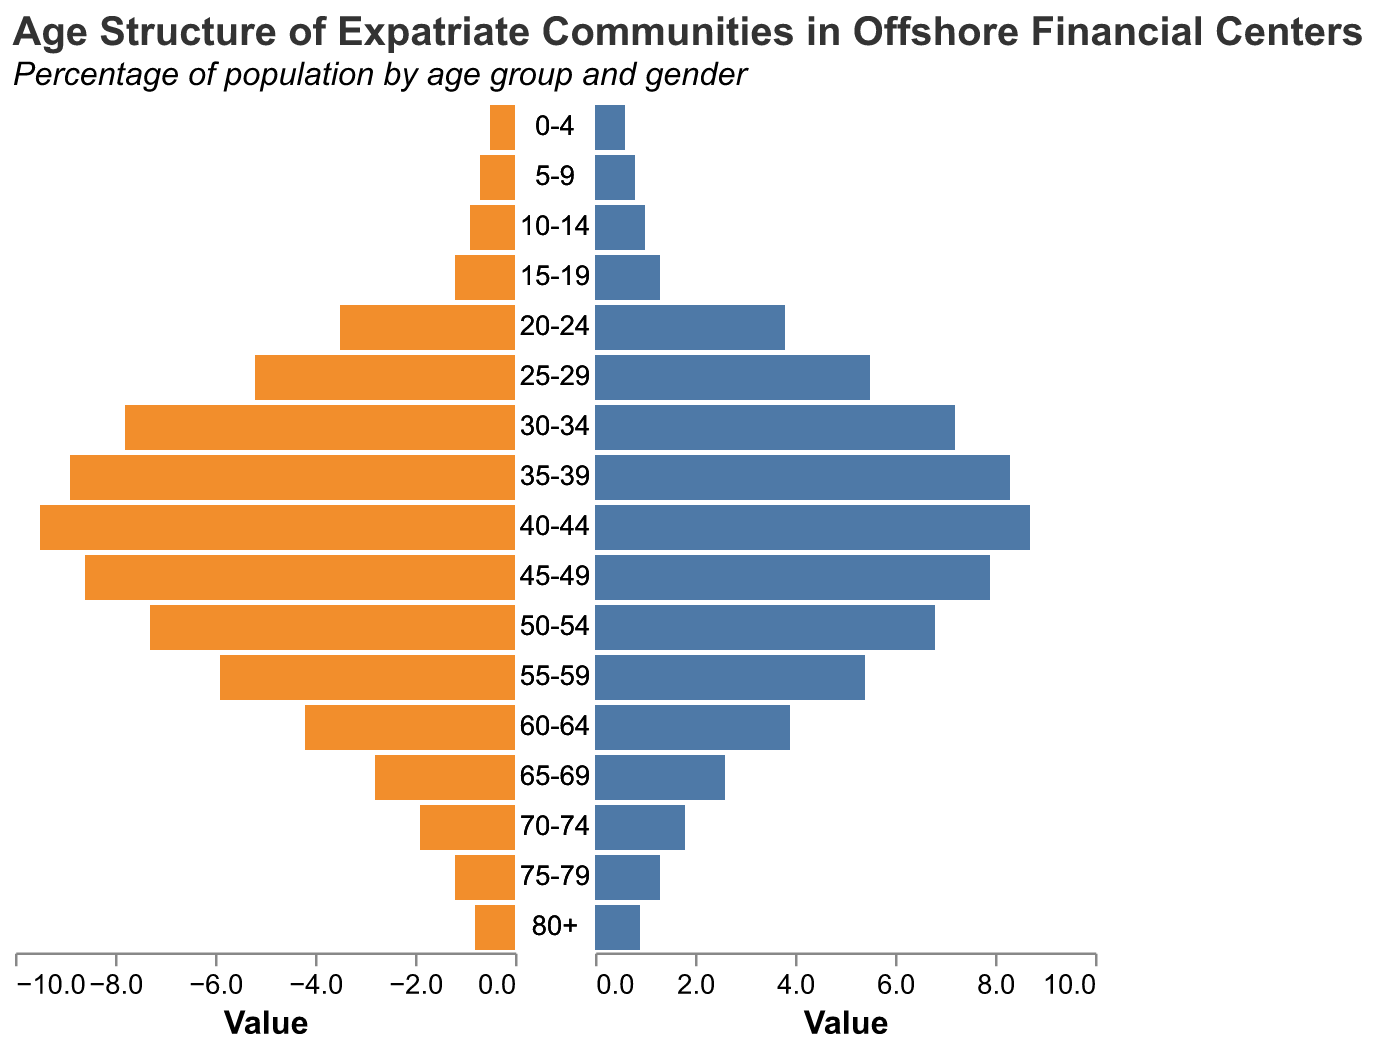What age group has the largest male population percentage? Examine the lengths of the bars representing males across all age groups. The longest bar is for 40-44 years old, indicating the largest male population percentage.
Answer: 40-44 What is the percentage difference between males and females in the 25-29 age group? The male percentage for 25-29 is 5.2%, and the female percentage is 5.5%. The difference is calculated as 5.5% - 5.2% = 0.3%.
Answer: 0.3% Which gender has a higher population percentage in the 75-79 age group? Compare the lengths of the bars representing males and females for the 75-79 age group. The female bar is slightly longer than the male bar.
Answer: Female What is the total population percentage for both males and females in the 30-34 age group? Add the percentages for males and females in the 30-34 age group: 7.8% (male) + 7.2% (female) = 15%.
Answer: 15% How does the population percentage of 20-24 year-old females compare to 60-64 year-old females? Look at the bar lengths for females in the 20-24 and 60-64 age groups. The 20-24 year-old female percentage (3.8%) is higher than the 60-64 year-old female percentage (3.9%).
Answer: 20-24 is higher What is the average population percentage of males for the age groups 0-4, 5-9, and 10-14? Add the male percentages for 0-4, 5-9, and 10-14 age groups: 0.5% + 0.7% + 0.9% = 2.1%. Divide by the number of age groups, which is 3. The average is 2.1% / 3 = 0.7%.
Answer: 0.7% In which age group do we see the largest decline in male population from one group to the next? Calculate the differences between consecutive male percentages. The largest decline is between 40-44 (9.5%) and 45-49 (8.6%), which is 9.5% - 8.6% = 0.9%.
Answer: 45-49 What percentage of the expatriate community is aged 70+? Sum the percentages of both genders in the age groups 70-74, 75-79, and 80+: (1.9% + 1.8%) + (1.2% + 1.3%) + (0.8% + 0.9%) = 8.9%.
Answer: 8.9% Which age group has a more balanced gender distribution? Smaller differences between male and female percentages indicate more balanced distribution. For age group 70-74, the percentages are 1.9% (male) and 1.8% (female), with a difference of only 0.1%.
Answer: 70-74 How many age groups have higher male percentages than female percentages? Compare the male and female bars in each age group. The age groups with higher male percentages than female percentages are: 30-34, 35-39, 40-44, 45-49, 50-54, 55-59, 60-64, 65-69, 70-74. There are 9 such age groups.
Answer: 9 